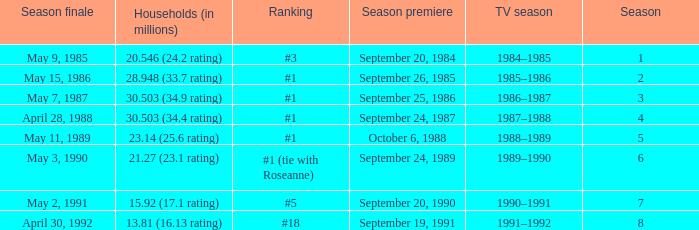Could you parse the entire table as a dict? {'header': ['Season finale', 'Households (in millions)', 'Ranking', 'Season premiere', 'TV season', 'Season'], 'rows': [['May 9, 1985', '20.546 (24.2 rating)', '#3', 'September 20, 1984', '1984–1985', '1'], ['May 15, 1986', '28.948 (33.7 rating)', '#1', 'September 26, 1985', '1985–1986', '2'], ['May 7, 1987', '30.503 (34.9 rating)', '#1', 'September 25, 1986', '1986–1987', '3'], ['April 28, 1988', '30.503 (34.4 rating)', '#1', 'September 24, 1987', '1987–1988', '4'], ['May 11, 1989', '23.14 (25.6 rating)', '#1', 'October 6, 1988', '1988–1989', '5'], ['May 3, 1990', '21.27 (23.1 rating)', '#1 (tie with Roseanne)', 'September 24, 1989', '1989–1990', '6'], ['May 2, 1991', '15.92 (17.1 rating)', '#5', 'September 20, 1990', '1990–1991', '7'], ['April 30, 1992', '13.81 (16.13 rating)', '#18', 'September 19, 1991', '1991–1992', '8']]} Which TV season has Households (in millions) of 30.503 (34.9 rating)? 1986–1987. 